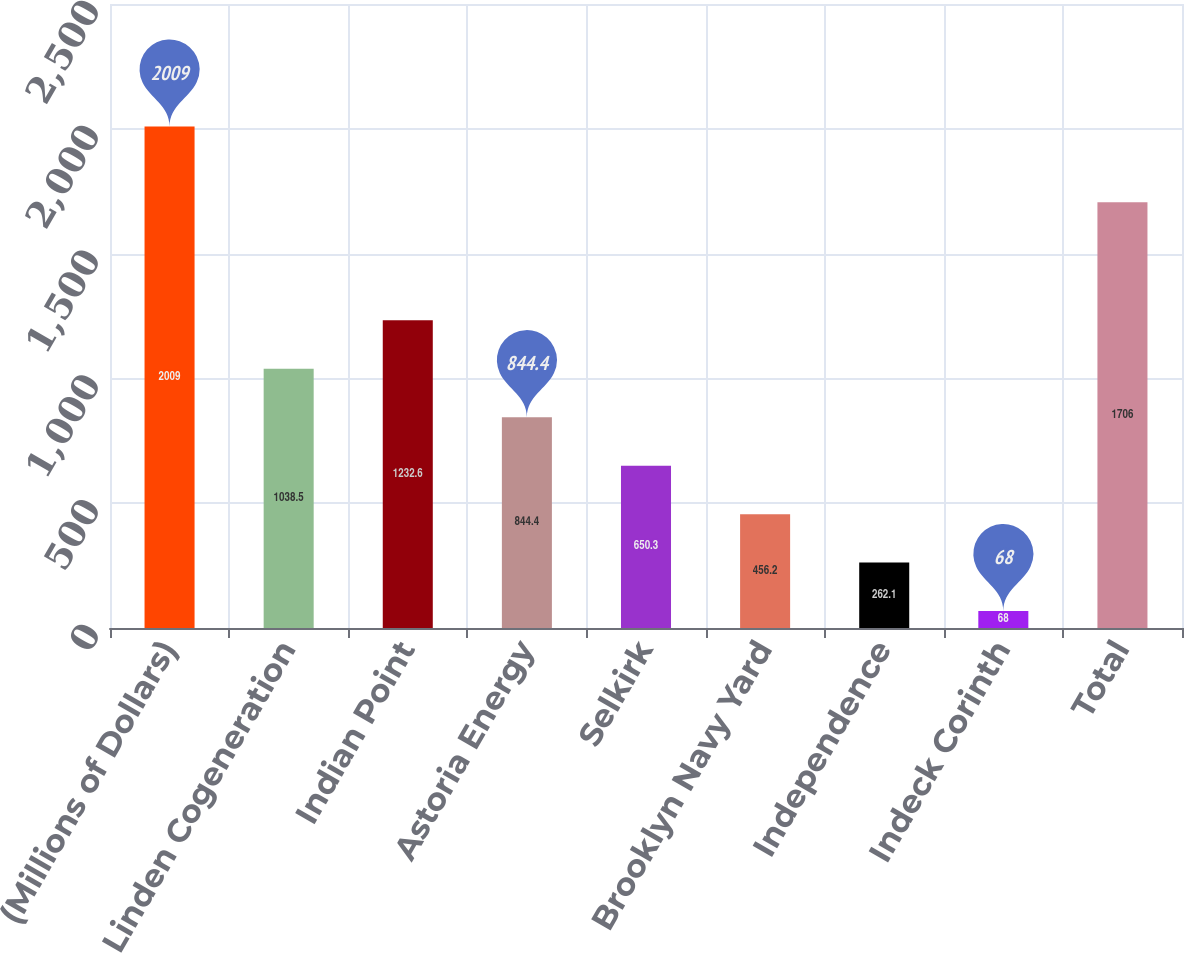Convert chart to OTSL. <chart><loc_0><loc_0><loc_500><loc_500><bar_chart><fcel>(Millions of Dollars)<fcel>Linden Cogeneration<fcel>Indian Point<fcel>Astoria Energy<fcel>Selkirk<fcel>Brooklyn Navy Yard<fcel>Independence<fcel>Indeck Corinth<fcel>Total<nl><fcel>2009<fcel>1038.5<fcel>1232.6<fcel>844.4<fcel>650.3<fcel>456.2<fcel>262.1<fcel>68<fcel>1706<nl></chart> 